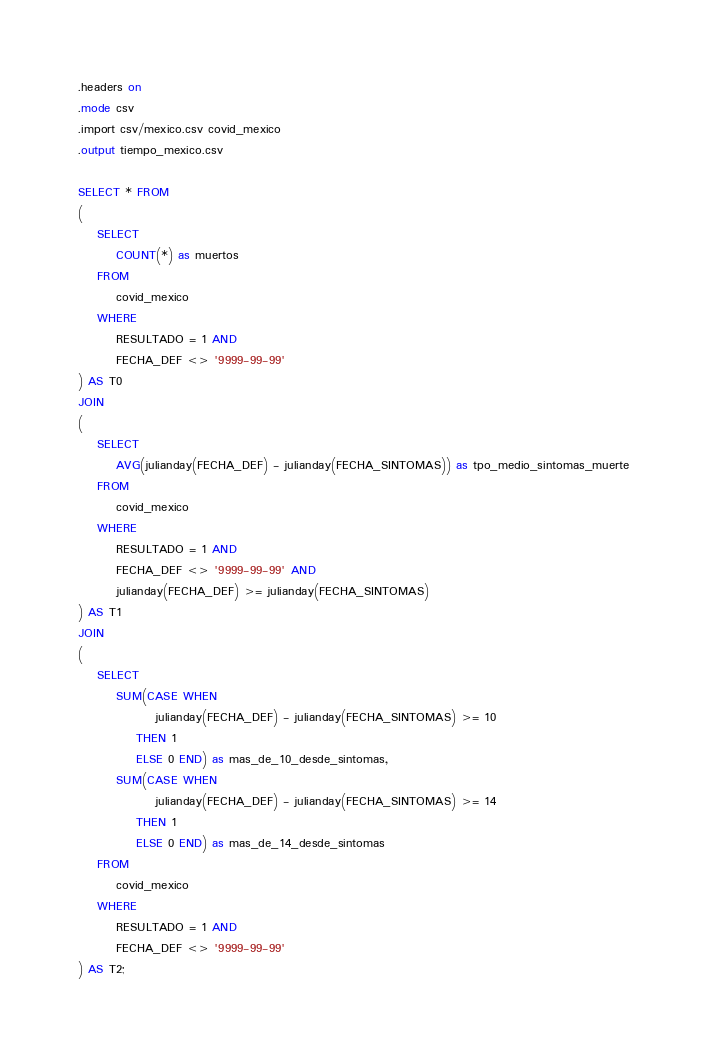Convert code to text. <code><loc_0><loc_0><loc_500><loc_500><_SQL_>.headers on
.mode csv
.import csv/mexico.csv covid_mexico
.output tiempo_mexico.csv

SELECT * FROM
(
    SELECT
        COUNT(*) as muertos
    FROM 
        covid_mexico
    WHERE
        RESULTADO = 1 AND
        FECHA_DEF <> '9999-99-99'
) AS T0
JOIN
(
    SELECT
        AVG(julianday(FECHA_DEF) - julianday(FECHA_SINTOMAS)) as tpo_medio_sintomas_muerte
    FROM 
        covid_mexico
    WHERE
        RESULTADO = 1 AND
        FECHA_DEF <> '9999-99-99' AND
        julianday(FECHA_DEF) >= julianday(FECHA_SINTOMAS)
) AS T1 
JOIN
(
    SELECT
        SUM(CASE WHEN 
                julianday(FECHA_DEF) - julianday(FECHA_SINTOMAS) >= 10 
            THEN 1 
            ELSE 0 END) as mas_de_10_desde_sintomas,
        SUM(CASE WHEN 
                julianday(FECHA_DEF) - julianday(FECHA_SINTOMAS) >= 14 
            THEN 1 
            ELSE 0 END) as mas_de_14_desde_sintomas
    FROM 
        covid_mexico
    WHERE
        RESULTADO = 1 AND
        FECHA_DEF <> '9999-99-99'
) AS T2;   
</code> 